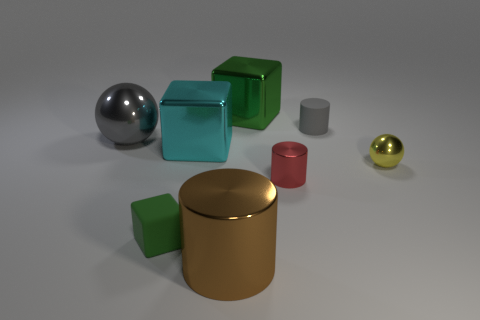Are there fewer large gray objects that are in front of the large cyan shiny thing than large brown metallic objects that are to the right of the green rubber cube?
Keep it short and to the point. Yes. What is the size of the thing that is the same color as the small matte block?
Ensure brevity in your answer.  Large. How many red things are to the left of the green thing that is in front of the big shiny cube to the right of the large cyan metal block?
Give a very brief answer. 0. Do the small matte block and the big sphere have the same color?
Keep it short and to the point. No. Are there any big matte cylinders of the same color as the small metal cylinder?
Make the answer very short. No. There is a cube that is the same size as the yellow metallic object; what is its color?
Keep it short and to the point. Green. Are there any yellow metallic things of the same shape as the cyan shiny thing?
Offer a terse response. No. What shape is the shiny object that is the same color as the tiny matte cube?
Your answer should be compact. Cube. Is there a gray thing on the right side of the green object left of the big block behind the matte cylinder?
Give a very brief answer. Yes. What is the shape of the cyan object that is the same size as the green shiny thing?
Offer a terse response. Cube. 